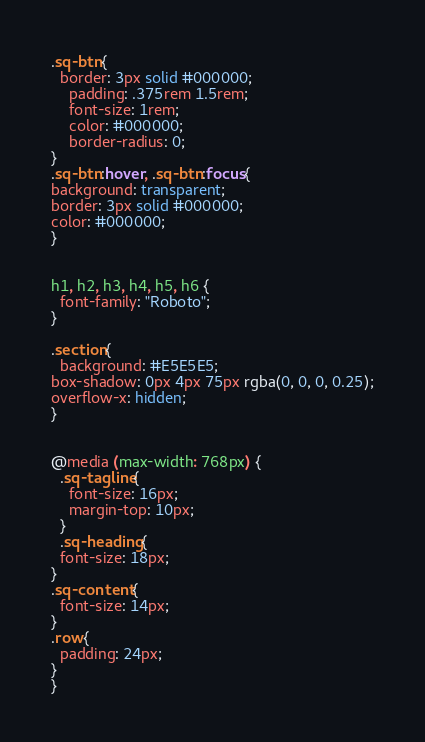Convert code to text. <code><loc_0><loc_0><loc_500><loc_500><_CSS_>.sq-btn{
  border: 3px solid #000000;
    padding: .375rem 1.5rem;
    font-size: 1rem;
    color: #000000;
    border-radius: 0;
}
.sq-btn:hover, .sq-btn:focus{
background: transparent;
border: 3px solid #000000;
color: #000000;
}


h1, h2, h3, h4, h5, h6 {
  font-family: "Roboto";
}

.section{
  background: #E5E5E5;
box-shadow: 0px 4px 75px rgba(0, 0, 0, 0.25);
overflow-x: hidden;
}


@media (max-width: 768px) {
  .sq-tagline{
    font-size: 16px;
    margin-top: 10px;
  }
  .sq-heading{
  font-size: 18px;
}
.sq-content{
  font-size: 14px;
}
.row{
  padding: 24px;
}
}</code> 